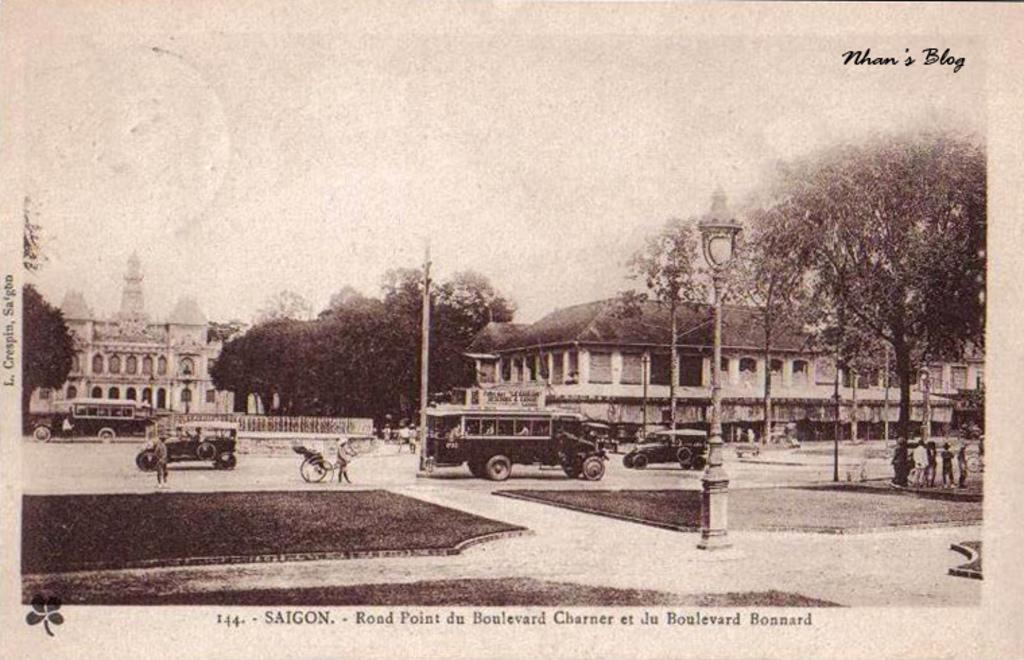Provide a one-sentence caption for the provided image. An old photograph shows a street scene in Siagon. 